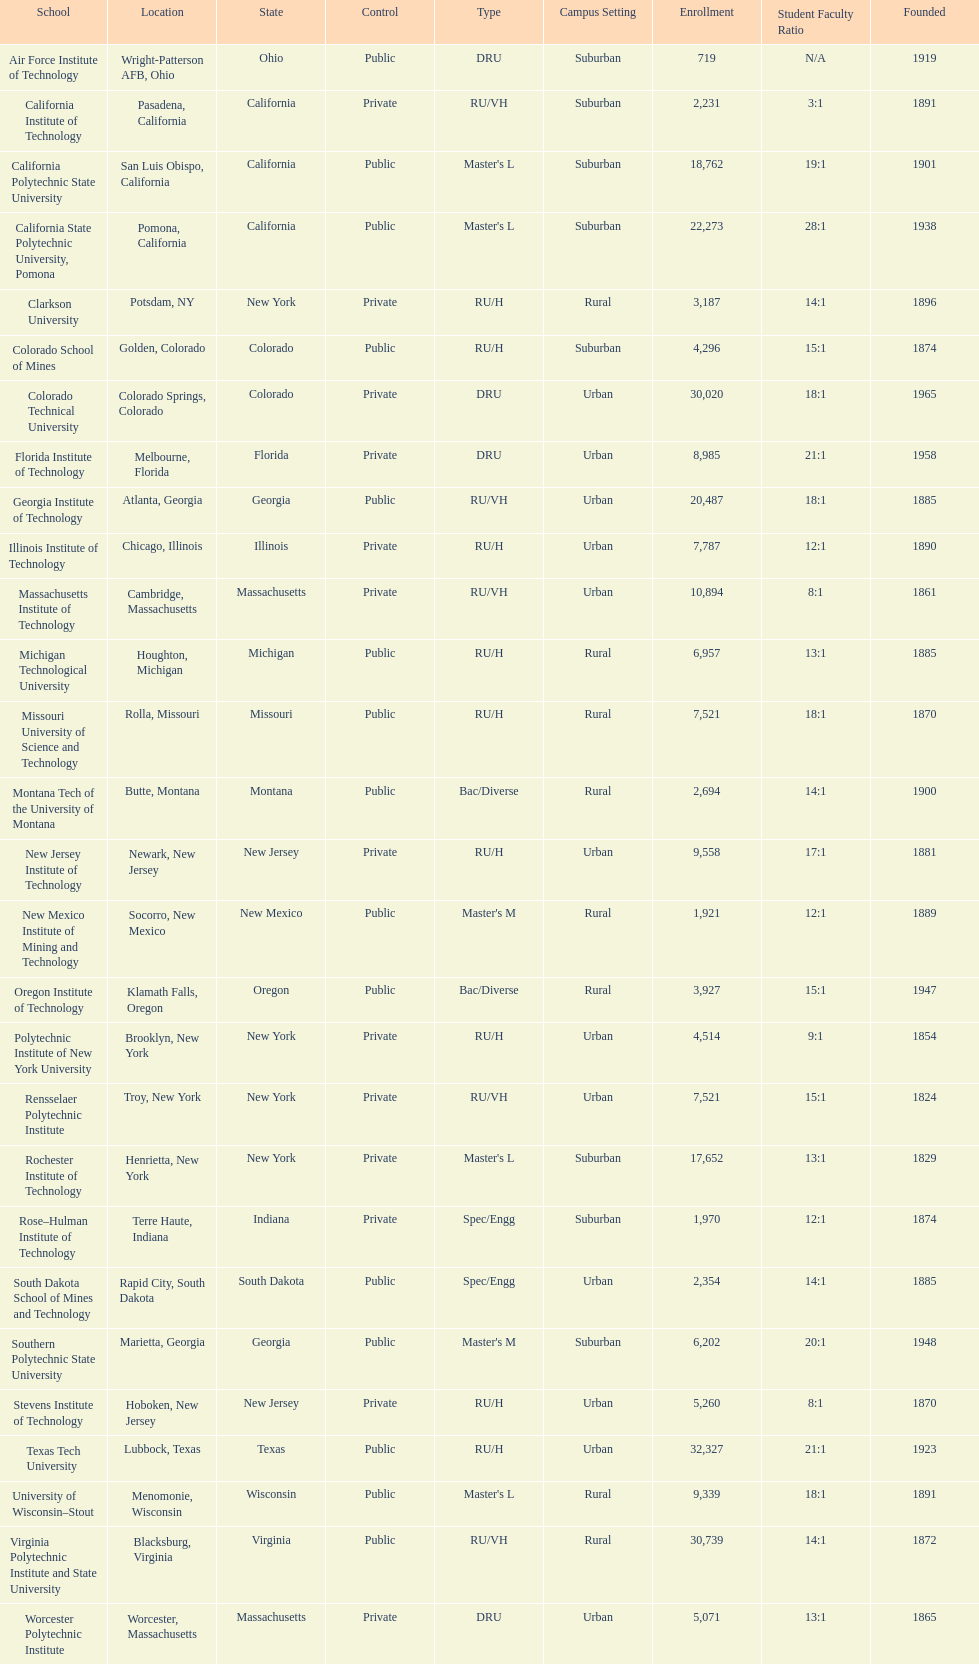How many of the universities were located in california? 3. 